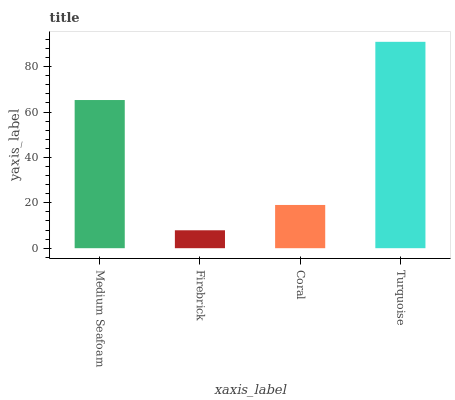Is Firebrick the minimum?
Answer yes or no. Yes. Is Turquoise the maximum?
Answer yes or no. Yes. Is Coral the minimum?
Answer yes or no. No. Is Coral the maximum?
Answer yes or no. No. Is Coral greater than Firebrick?
Answer yes or no. Yes. Is Firebrick less than Coral?
Answer yes or no. Yes. Is Firebrick greater than Coral?
Answer yes or no. No. Is Coral less than Firebrick?
Answer yes or no. No. Is Medium Seafoam the high median?
Answer yes or no. Yes. Is Coral the low median?
Answer yes or no. Yes. Is Firebrick the high median?
Answer yes or no. No. Is Medium Seafoam the low median?
Answer yes or no. No. 